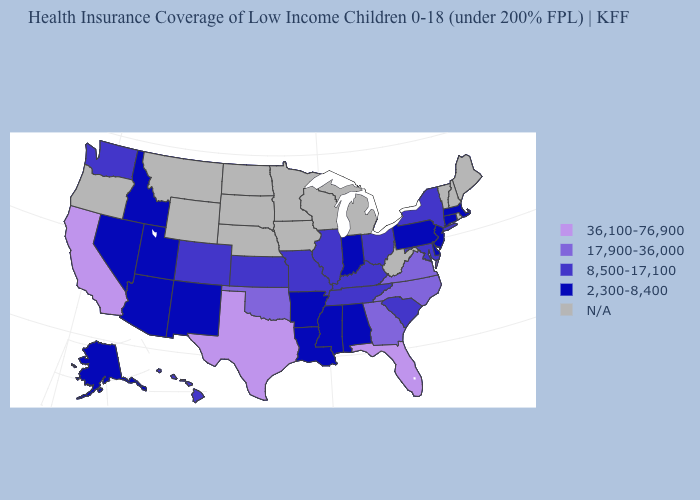What is the value of South Carolina?
Write a very short answer. 8,500-17,100. What is the lowest value in the USA?
Keep it brief. 2,300-8,400. What is the highest value in the USA?
Write a very short answer. 36,100-76,900. What is the value of South Dakota?
Short answer required. N/A. Name the states that have a value in the range 36,100-76,900?
Short answer required. California, Florida, Texas. Name the states that have a value in the range N/A?
Write a very short answer. Iowa, Maine, Michigan, Minnesota, Montana, Nebraska, New Hampshire, North Dakota, Oregon, Rhode Island, South Dakota, Vermont, West Virginia, Wisconsin, Wyoming. Name the states that have a value in the range N/A?
Quick response, please. Iowa, Maine, Michigan, Minnesota, Montana, Nebraska, New Hampshire, North Dakota, Oregon, Rhode Island, South Dakota, Vermont, West Virginia, Wisconsin, Wyoming. How many symbols are there in the legend?
Be succinct. 5. What is the lowest value in the West?
Concise answer only. 2,300-8,400. What is the value of Maryland?
Short answer required. 8,500-17,100. Which states have the highest value in the USA?
Concise answer only. California, Florida, Texas. Which states have the lowest value in the USA?
Write a very short answer. Alabama, Alaska, Arizona, Arkansas, Connecticut, Delaware, Idaho, Indiana, Louisiana, Massachusetts, Mississippi, Nevada, New Jersey, New Mexico, Pennsylvania, Utah. Name the states that have a value in the range N/A?
Keep it brief. Iowa, Maine, Michigan, Minnesota, Montana, Nebraska, New Hampshire, North Dakota, Oregon, Rhode Island, South Dakota, Vermont, West Virginia, Wisconsin, Wyoming. Does the first symbol in the legend represent the smallest category?
Short answer required. No. 